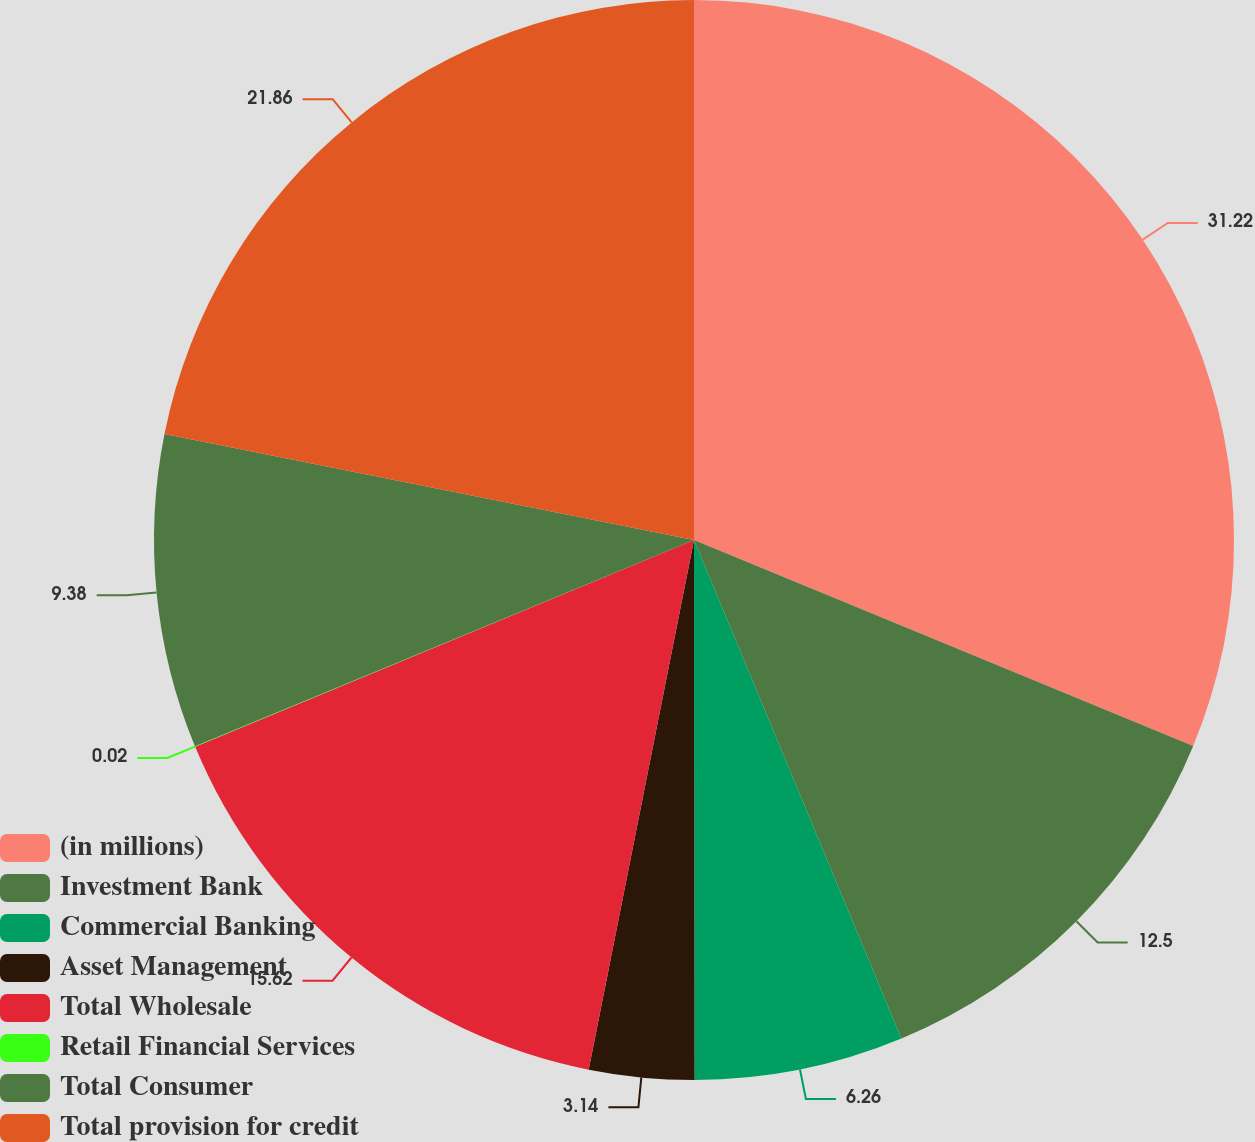Convert chart. <chart><loc_0><loc_0><loc_500><loc_500><pie_chart><fcel>(in millions)<fcel>Investment Bank<fcel>Commercial Banking<fcel>Asset Management<fcel>Total Wholesale<fcel>Retail Financial Services<fcel>Total Consumer<fcel>Total provision for credit<nl><fcel>31.23%<fcel>12.5%<fcel>6.26%<fcel>3.14%<fcel>15.62%<fcel>0.02%<fcel>9.38%<fcel>21.86%<nl></chart> 